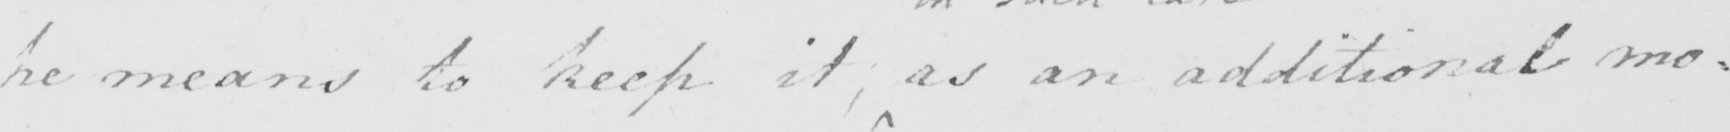What text is written in this handwritten line? he means to keep it , as an additional mo= 